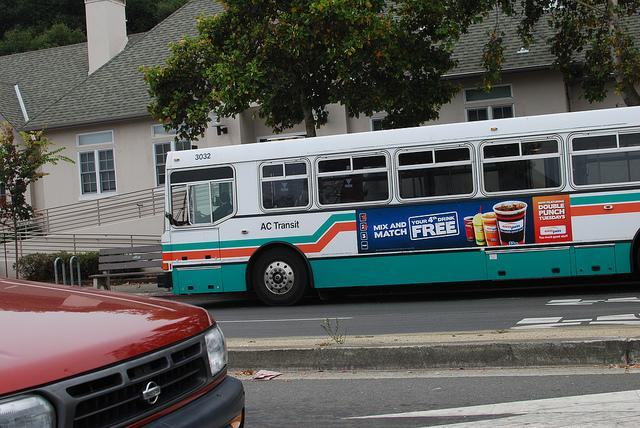What day is Double Punch? tuesday 